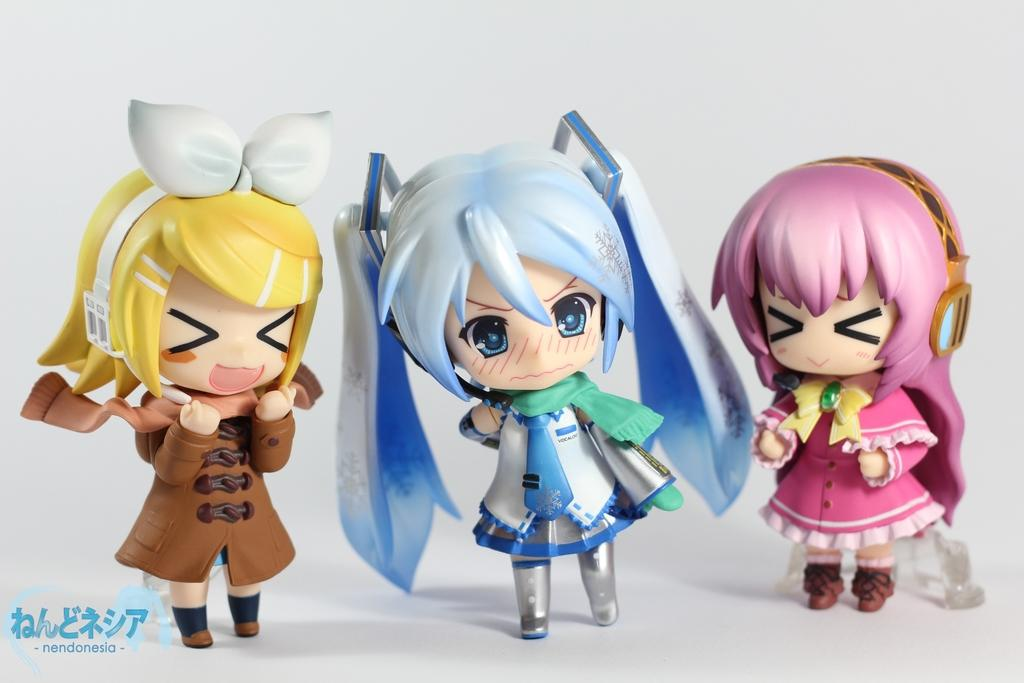What type of objects can be seen in the image? There are toys in the image. What type of bread can be seen in the image? There is no bread present in the image; it only contains toys. 